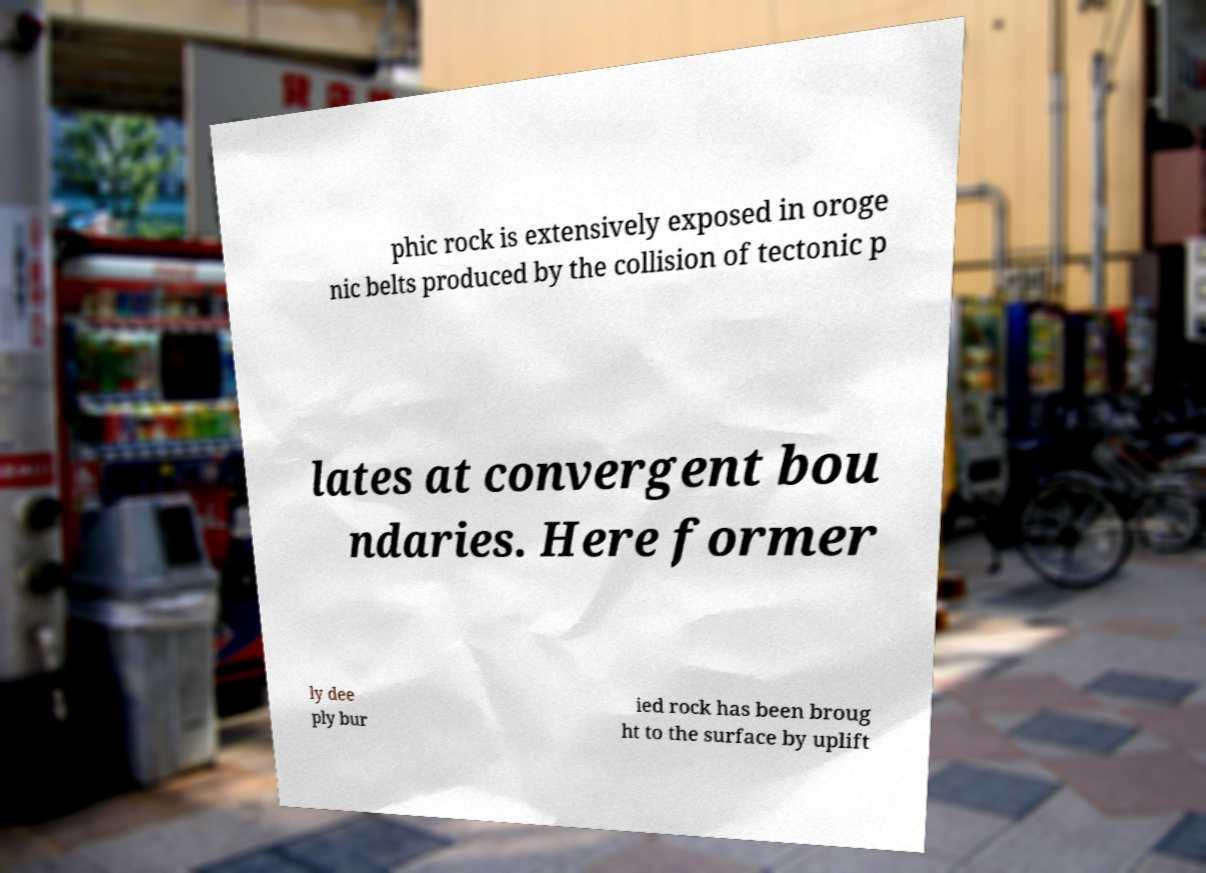For documentation purposes, I need the text within this image transcribed. Could you provide that? phic rock is extensively exposed in oroge nic belts produced by the collision of tectonic p lates at convergent bou ndaries. Here former ly dee ply bur ied rock has been broug ht to the surface by uplift 